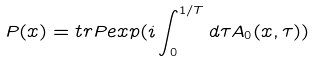<formula> <loc_0><loc_0><loc_500><loc_500>P ( x ) = t r P e x p ( i \int _ { 0 } ^ { 1 / T } d \tau A _ { 0 } ( x , \tau ) )</formula> 